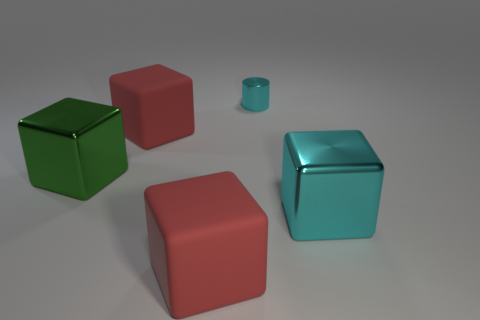What mood does the color scheme of the objects convey? The color scheme of the objects, with its cool tones of reds and greens alongside the metallic turquoise, suggests a modern and clean aesthetic. The colors are somewhat muted, giving the scene a calm, harmonious feel. 